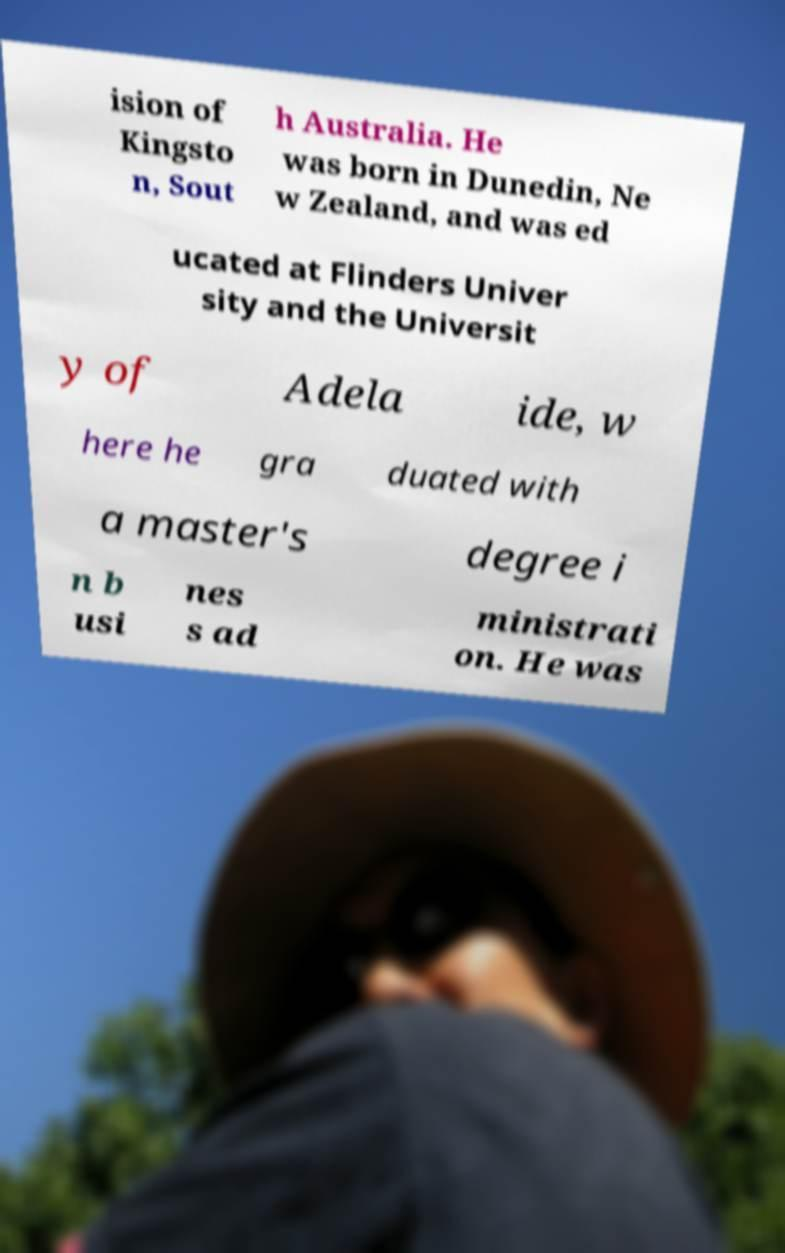Please read and relay the text visible in this image. What does it say? ision of Kingsto n, Sout h Australia. He was born in Dunedin, Ne w Zealand, and was ed ucated at Flinders Univer sity and the Universit y of Adela ide, w here he gra duated with a master's degree i n b usi nes s ad ministrati on. He was 